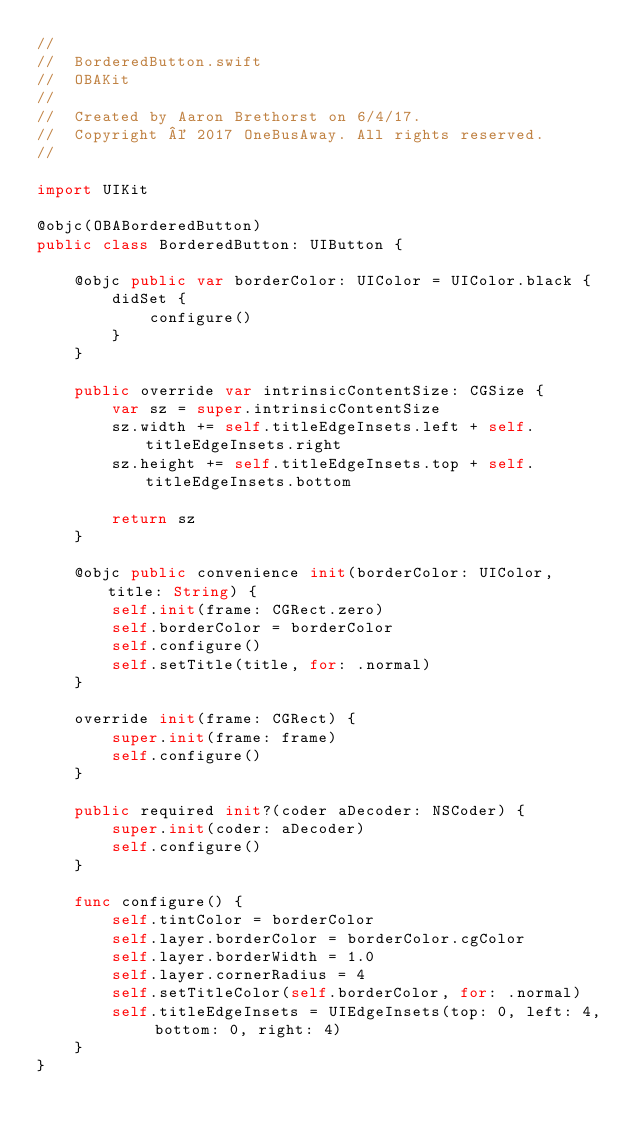<code> <loc_0><loc_0><loc_500><loc_500><_Swift_>//
//  BorderedButton.swift
//  OBAKit
//
//  Created by Aaron Brethorst on 6/4/17.
//  Copyright © 2017 OneBusAway. All rights reserved.
//

import UIKit

@objc(OBABorderedButton)
public class BorderedButton: UIButton {

    @objc public var borderColor: UIColor = UIColor.black {
        didSet {
            configure()
        }
    }

    public override var intrinsicContentSize: CGSize {
        var sz = super.intrinsicContentSize
        sz.width += self.titleEdgeInsets.left + self.titleEdgeInsets.right
        sz.height += self.titleEdgeInsets.top + self.titleEdgeInsets.bottom

        return sz
    }

    @objc public convenience init(borderColor: UIColor, title: String) {
        self.init(frame: CGRect.zero)
        self.borderColor = borderColor
        self.configure()
        self.setTitle(title, for: .normal)
    }

    override init(frame: CGRect) {
        super.init(frame: frame)
        self.configure()
    }

    public required init?(coder aDecoder: NSCoder) {
        super.init(coder: aDecoder)
        self.configure()
    }

    func configure() {
        self.tintColor = borderColor
        self.layer.borderColor = borderColor.cgColor
        self.layer.borderWidth = 1.0
        self.layer.cornerRadius = 4
        self.setTitleColor(self.borderColor, for: .normal)
        self.titleEdgeInsets = UIEdgeInsets(top: 0, left: 4, bottom: 0, right: 4)
    }
}
</code> 